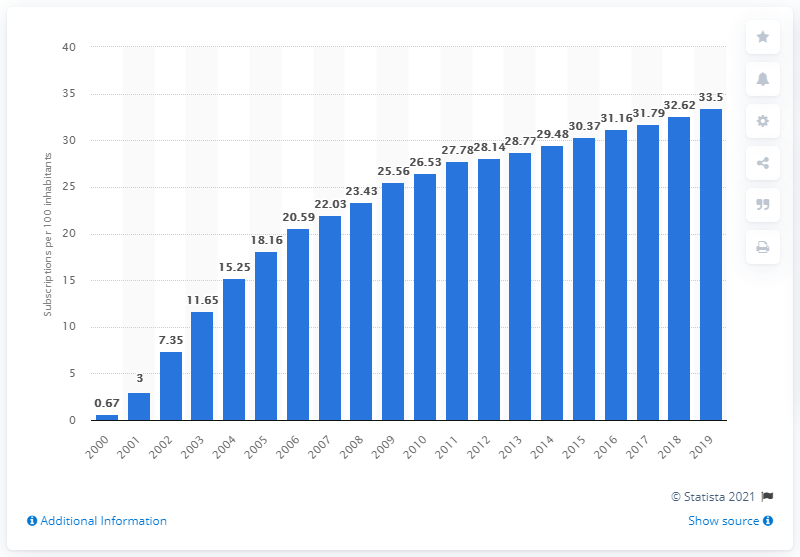Draw attention to some important aspects in this diagram. The number of fixed broadband subscriptions per 100 inhabitants in Japan fluctuated between 33.5 in 2000 and 2019, according to available data. 